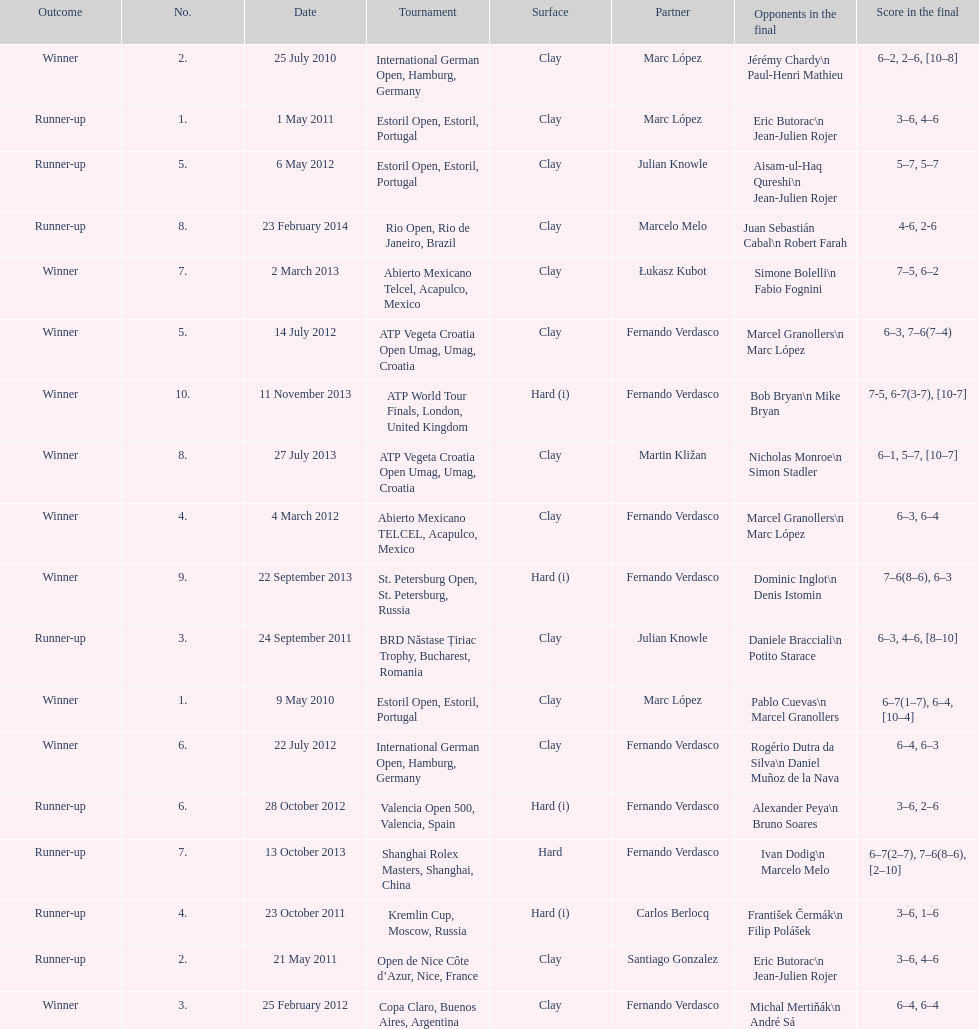Which tournament has the largest number? ATP World Tour Finals. 